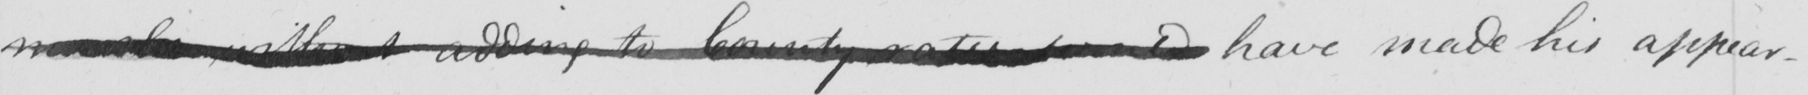Can you tell me what this handwritten text says? morals without adding to County rates would have made his appear- 